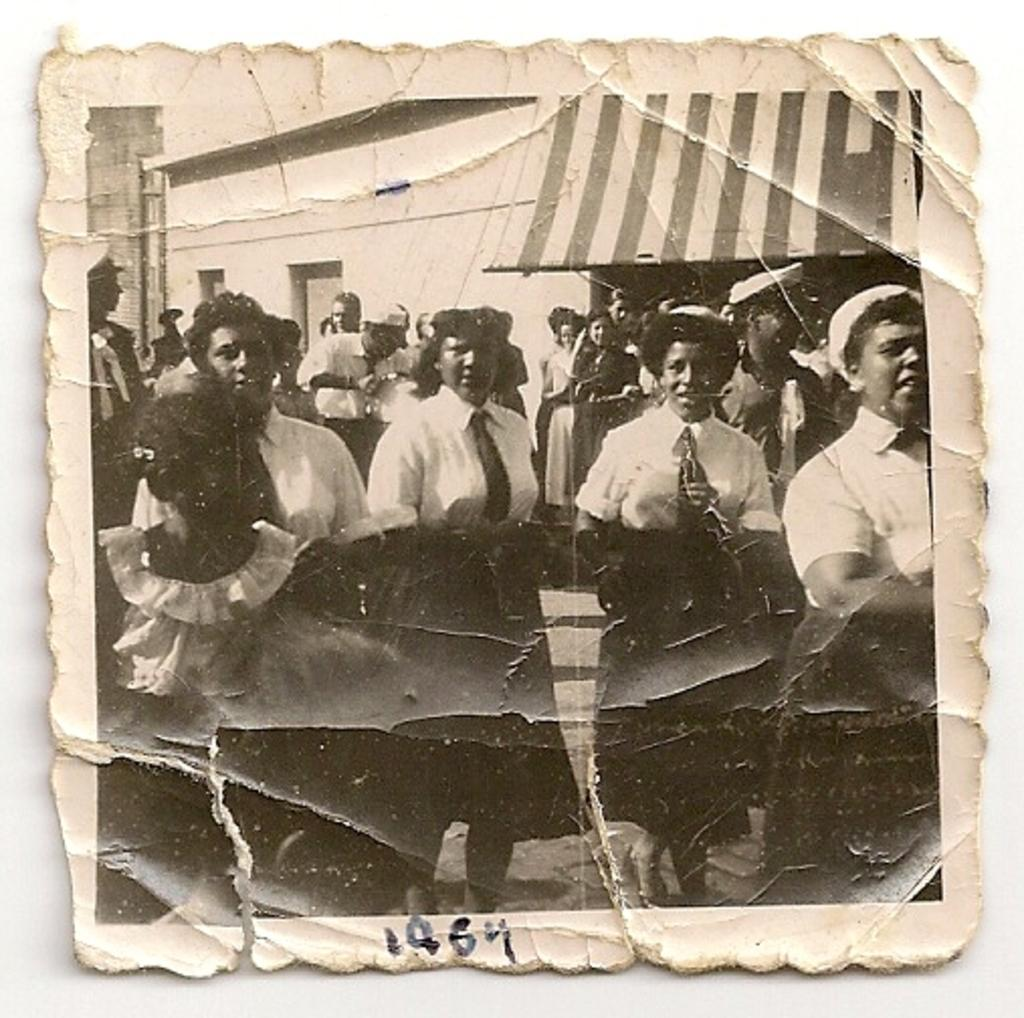What is the main subject of the image? The main subject of the image is a photograph. What can be seen in the center of the photograph? There are people wearing uniforms in the center of the image. What is visible in the background of the photograph? There is a shed in the background of the image. Can you tell me how many kittens are playing on the trail in the image? There is no trail or kittens present in the image; it features a photograph with people wearing uniforms and a shed in the background. 